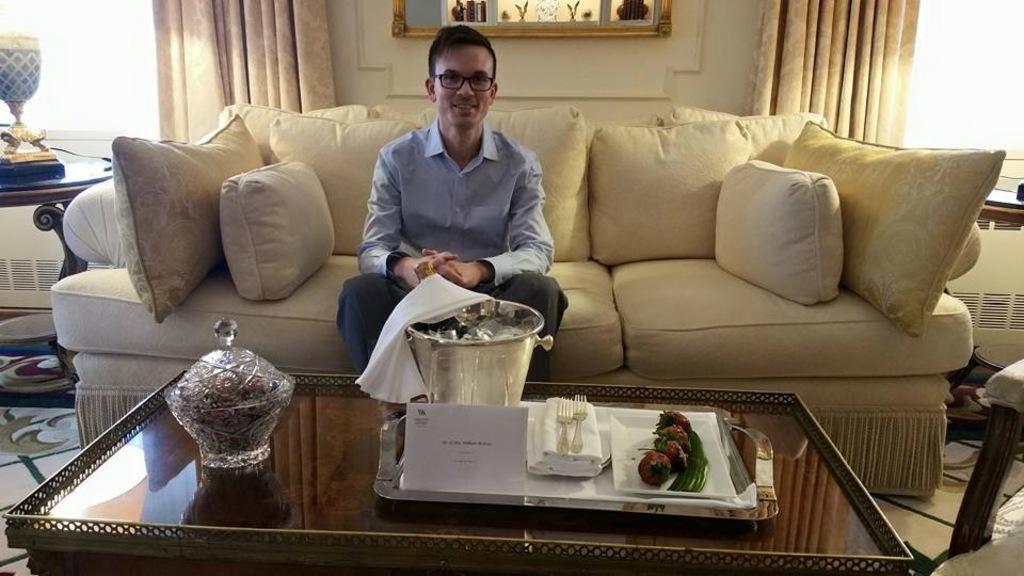What is the man in the image doing? The man is sitting in the sofa. What expression does the man have? The man is smiling. What can be seen on the table in the image? There is a bucket with ice cubes, a tray, forks, and a cloth on the table. What is visible in the background of the image? There is a window, a curtain associated with the window, and a wall in the background. What song is the man singing in the image? There is no indication in the image that the man is singing a song, so it cannot be determined from the picture. 